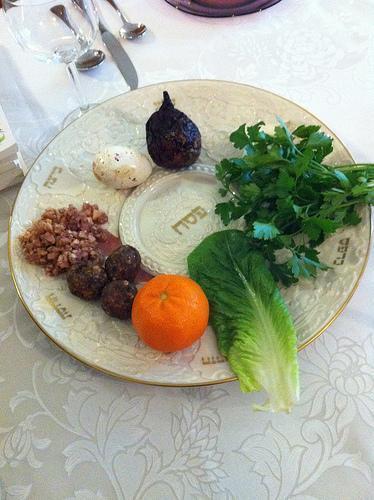How many different food items are on the plate?
Give a very brief answer. 7. How many spoons are in the photo?
Give a very brief answer. 2. 